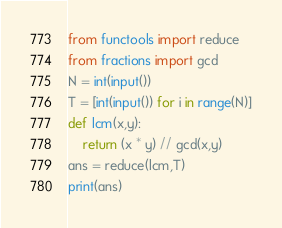Convert code to text. <code><loc_0><loc_0><loc_500><loc_500><_Python_>from functools import reduce
from fractions import gcd
N = int(input())
T = [int(input()) for i in range(N)]
def lcm(x,y):
    return (x * y) // gcd(x,y)
ans = reduce(lcm,T)
print(ans)</code> 